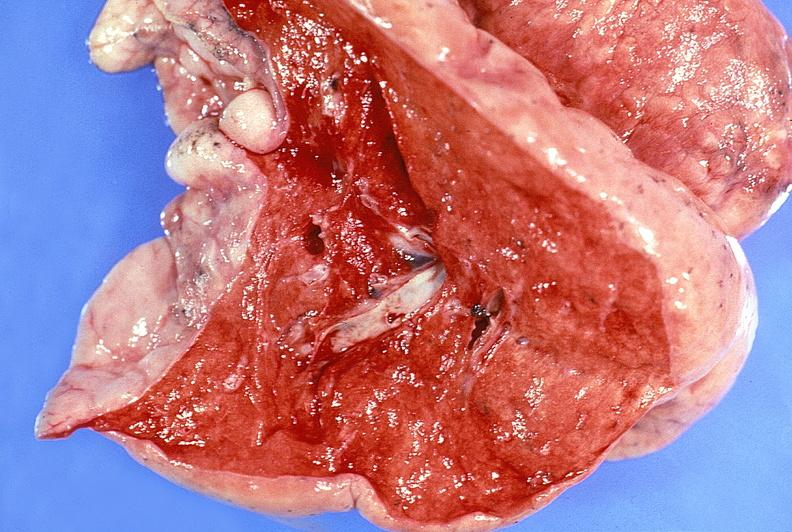what does this image show?
Answer the question using a single word or phrase. Normal lung 